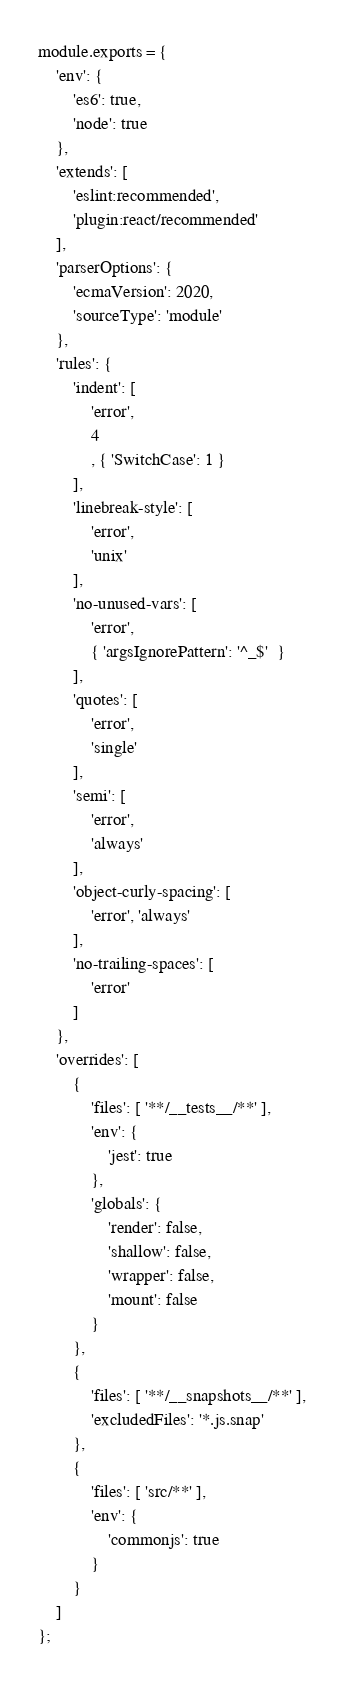<code> <loc_0><loc_0><loc_500><loc_500><_JavaScript_>module.exports = {
    'env': {
        'es6': true,
        'node': true
    },
    'extends': [
        'eslint:recommended',
        'plugin:react/recommended'
    ],
    'parserOptions': {
        'ecmaVersion': 2020,
        'sourceType': 'module'
    },
    'rules': {
        'indent': [
            'error',
            4
            , { 'SwitchCase': 1 }
        ],
        'linebreak-style': [
            'error',
            'unix'
        ],
        'no-unused-vars': [
            'error',
            { 'argsIgnorePattern': '^_$'  }
        ],
        'quotes': [
            'error',
            'single'
        ],
        'semi': [
            'error',
            'always'
        ],
        'object-curly-spacing': [
            'error', 'always'
        ],
        'no-trailing-spaces': [
            'error'
        ]
    },
    'overrides': [
        {
            'files': [ '**/__tests__/**' ],
            'env': {
                'jest': true
            },
            'globals': {
                'render': false,
                'shallow': false,
                'wrapper': false,
                'mount': false
            }
        },
        {
            'files': [ '**/__snapshots__/**' ],
            'excludedFiles': '*.js.snap'
        },
        {
            'files': [ 'src/**' ],
            'env': {
                'commonjs': true
            }
        }
    ]
};
</code> 